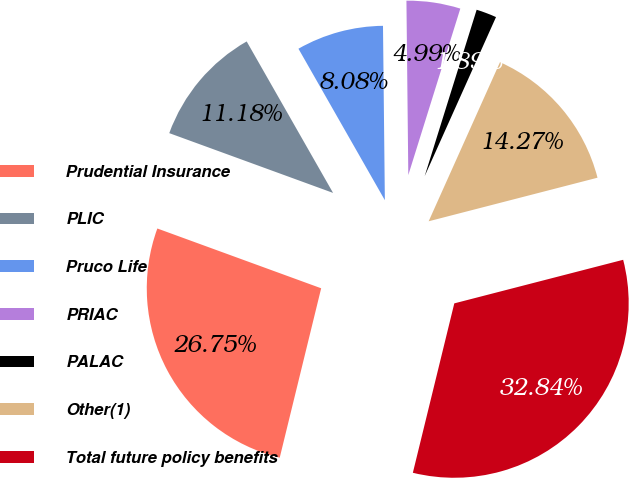<chart> <loc_0><loc_0><loc_500><loc_500><pie_chart><fcel>Prudential Insurance<fcel>PLIC<fcel>Pruco Life<fcel>PRIAC<fcel>PALAC<fcel>Other(1)<fcel>Total future policy benefits<nl><fcel>26.75%<fcel>11.18%<fcel>8.08%<fcel>4.99%<fcel>1.89%<fcel>14.27%<fcel>32.84%<nl></chart> 